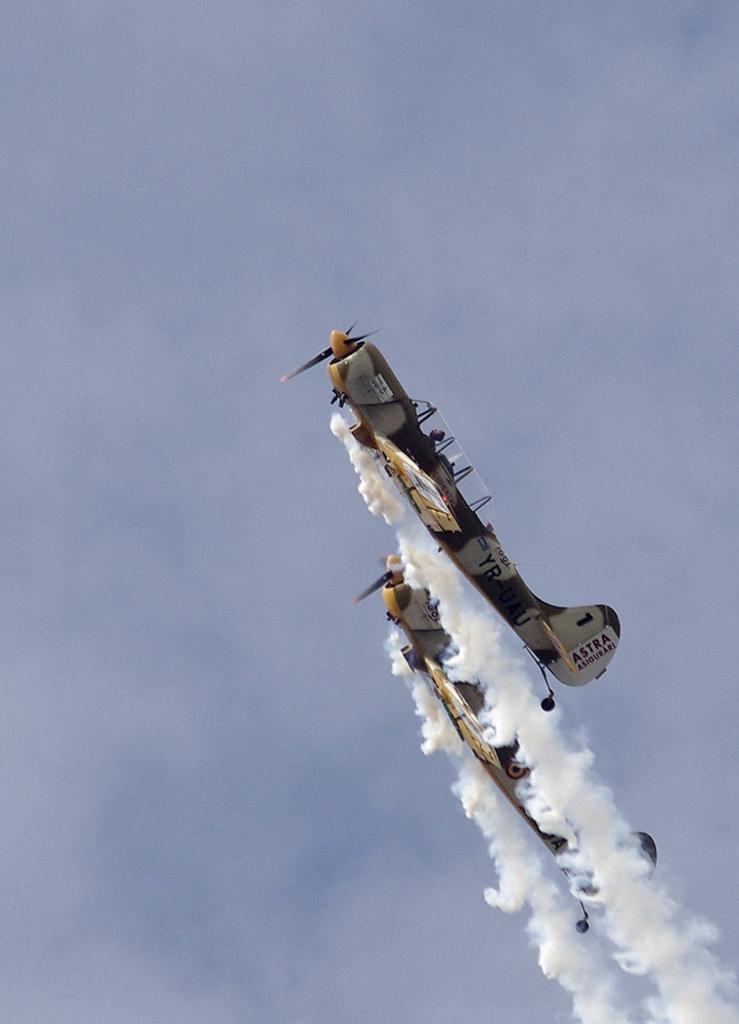How many aeroplanes are present in the image? There are two aeroplanes in the image. What are the aeroplanes doing in the image? The aeroplanes are flying at the right side of the image. What can be observed coming out of the aeroplanes? White-colored smoke is releasing from the aeroplanes. What is visible in the background of the image? The background of the image includes the sky. What type of lunchroom can be seen in the image? There is no lunchroom present in the image; it features two aeroplanes flying and releasing white-colored smoke. Are there any ghosts visible in the image? There are no ghosts present in the image. 